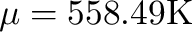<formula> <loc_0><loc_0><loc_500><loc_500>\mu = 5 5 8 . 4 9 K</formula> 